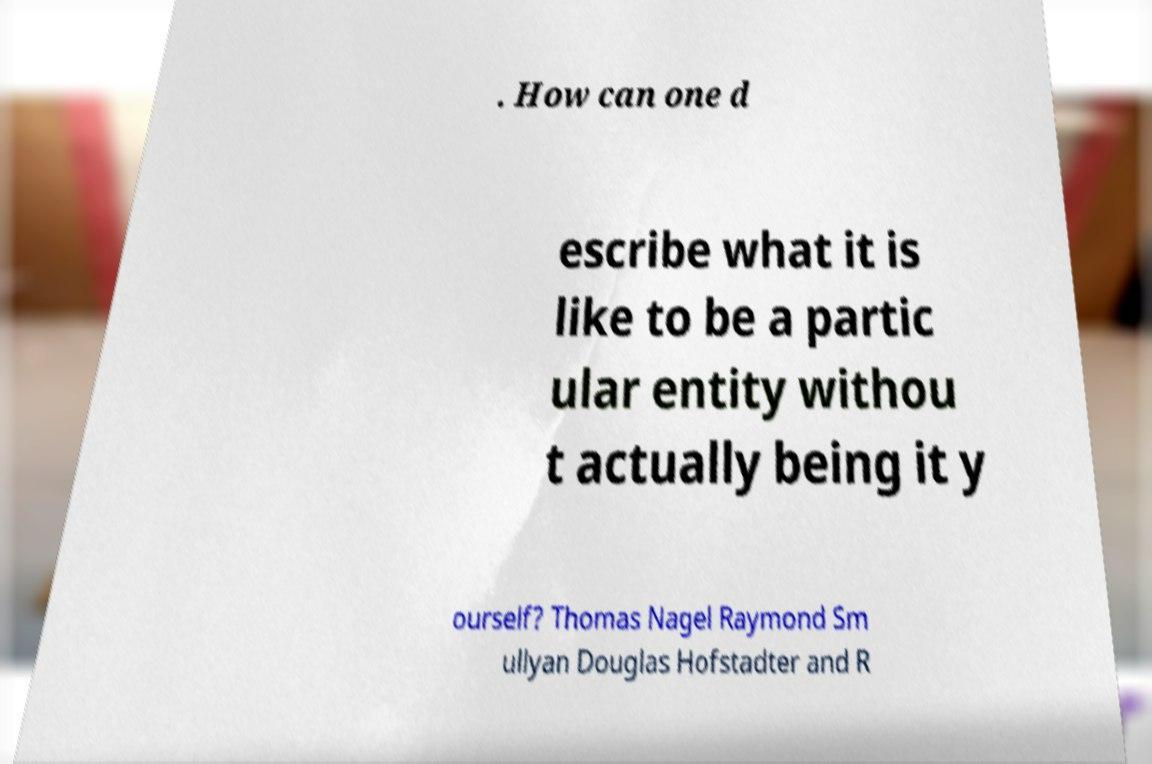What messages or text are displayed in this image? I need them in a readable, typed format. . How can one d escribe what it is like to be a partic ular entity withou t actually being it y ourself? Thomas Nagel Raymond Sm ullyan Douglas Hofstadter and R 